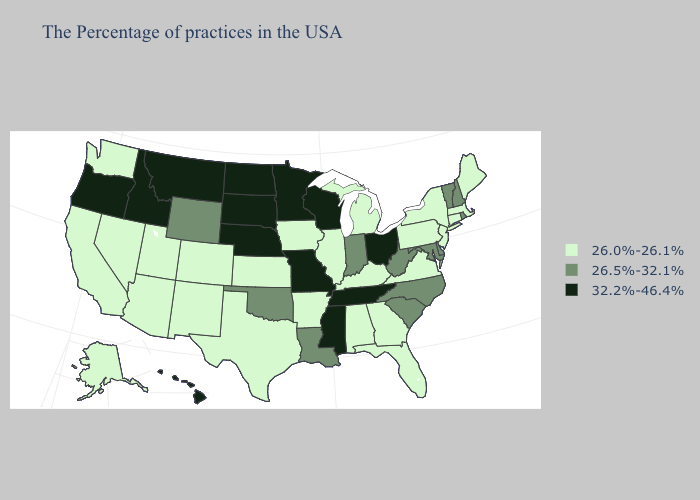What is the value of North Carolina?
Write a very short answer. 26.5%-32.1%. Name the states that have a value in the range 26.5%-32.1%?
Keep it brief. Rhode Island, New Hampshire, Vermont, Delaware, Maryland, North Carolina, South Carolina, West Virginia, Indiana, Louisiana, Oklahoma, Wyoming. Name the states that have a value in the range 32.2%-46.4%?
Short answer required. Ohio, Tennessee, Wisconsin, Mississippi, Missouri, Minnesota, Nebraska, South Dakota, North Dakota, Montana, Idaho, Oregon, Hawaii. Name the states that have a value in the range 26.5%-32.1%?
Answer briefly. Rhode Island, New Hampshire, Vermont, Delaware, Maryland, North Carolina, South Carolina, West Virginia, Indiana, Louisiana, Oklahoma, Wyoming. What is the value of Ohio?
Answer briefly. 32.2%-46.4%. Name the states that have a value in the range 26.0%-26.1%?
Write a very short answer. Maine, Massachusetts, Connecticut, New York, New Jersey, Pennsylvania, Virginia, Florida, Georgia, Michigan, Kentucky, Alabama, Illinois, Arkansas, Iowa, Kansas, Texas, Colorado, New Mexico, Utah, Arizona, Nevada, California, Washington, Alaska. How many symbols are there in the legend?
Answer briefly. 3. Which states have the lowest value in the Northeast?
Concise answer only. Maine, Massachusetts, Connecticut, New York, New Jersey, Pennsylvania. What is the highest value in states that border Maryland?
Be succinct. 26.5%-32.1%. Among the states that border Nevada , does Oregon have the highest value?
Concise answer only. Yes. Does Wisconsin have the highest value in the MidWest?
Write a very short answer. Yes. Does Minnesota have the highest value in the USA?
Keep it brief. Yes. What is the value of Maryland?
Short answer required. 26.5%-32.1%. What is the lowest value in the Northeast?
Give a very brief answer. 26.0%-26.1%. What is the value of Missouri?
Keep it brief. 32.2%-46.4%. 